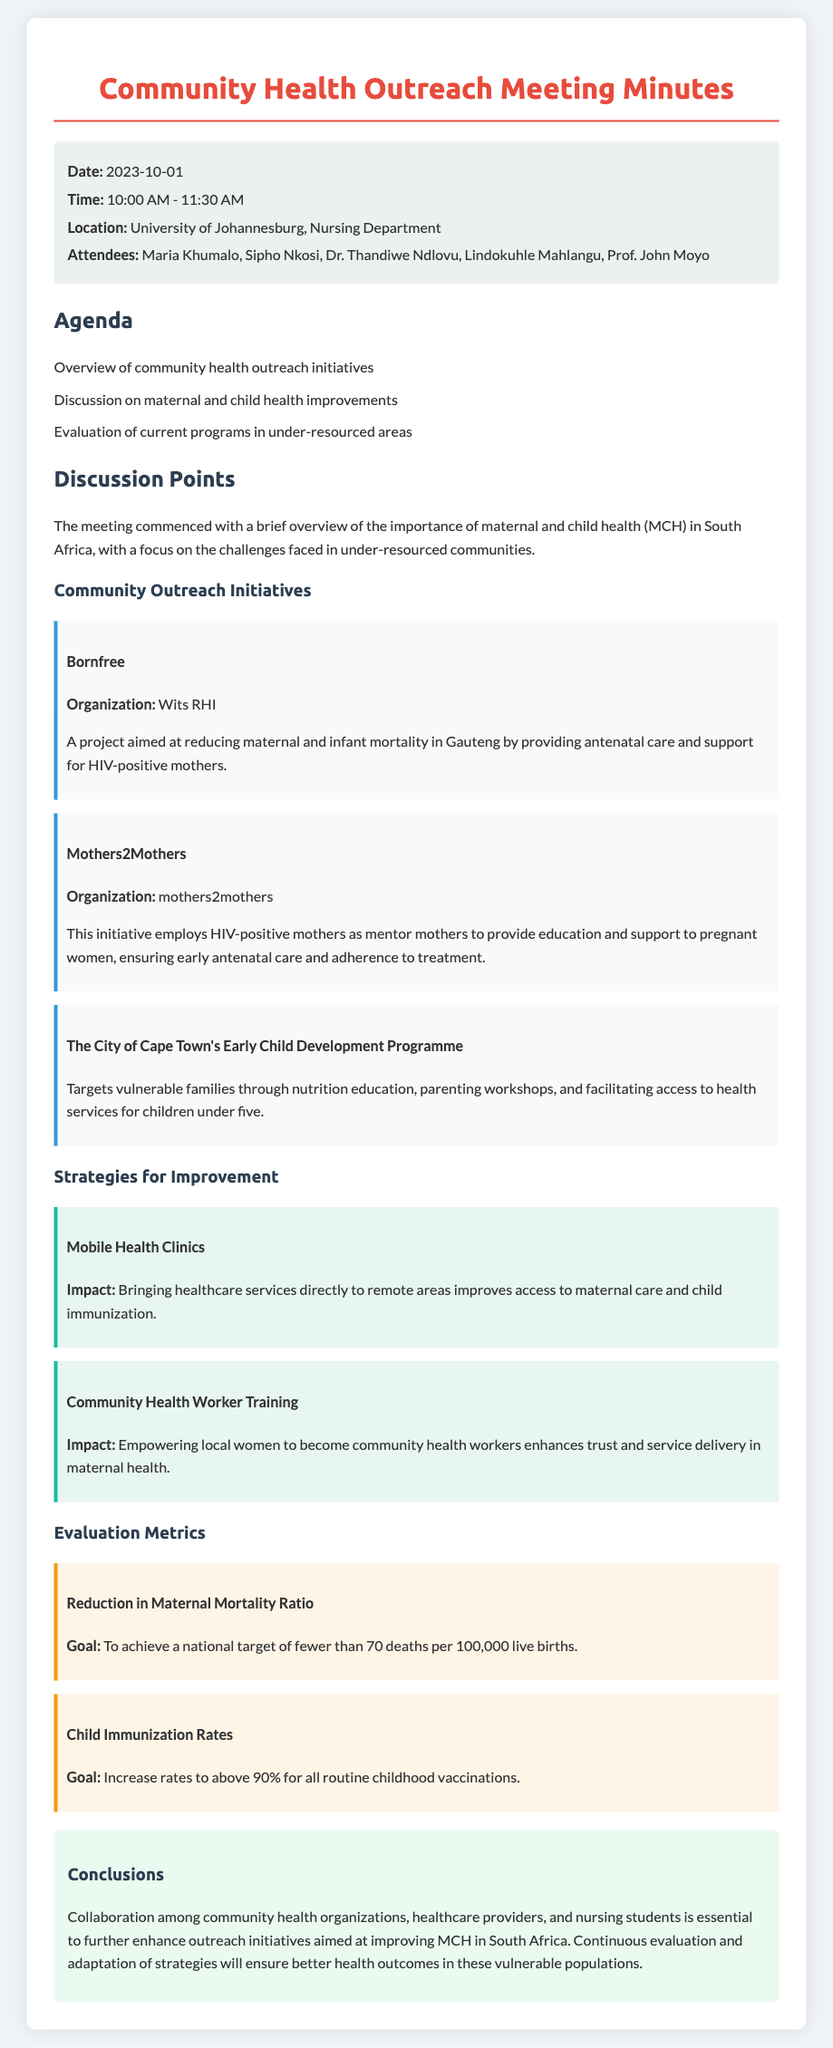what is the date of the meeting? The date of the meeting is stated in the meeting information section.
Answer: 2023-10-01 who is one of the attendees? The attendees are listed in the meeting information, and one of them is mentioned.
Answer: Maria Khumalo what is the goal for child immunization rates? The goal for child immunization rates is specified in the evaluation metrics section.
Answer: Increase rates to above 90% what organization is associated with the initiative "Bornfree"? The document specifies the organization linked to the initiative.
Answer: Wits RHI what impact does mobile health clinics aim to achieve? The impact of mobile health clinics is described in the strategies for improvement section.
Answer: Improves access to maternal care and child immunization how many strategies for improvement are discussed? The document lists multiple strategies under the respective section.
Answer: Two 